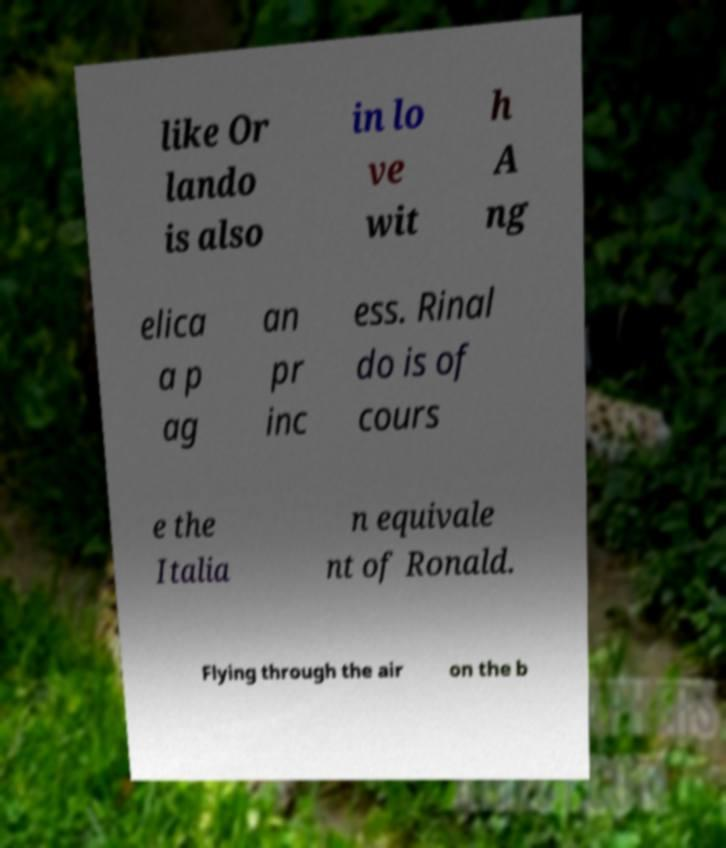Can you read and provide the text displayed in the image?This photo seems to have some interesting text. Can you extract and type it out for me? like Or lando is also in lo ve wit h A ng elica a p ag an pr inc ess. Rinal do is of cours e the Italia n equivale nt of Ronald. Flying through the air on the b 